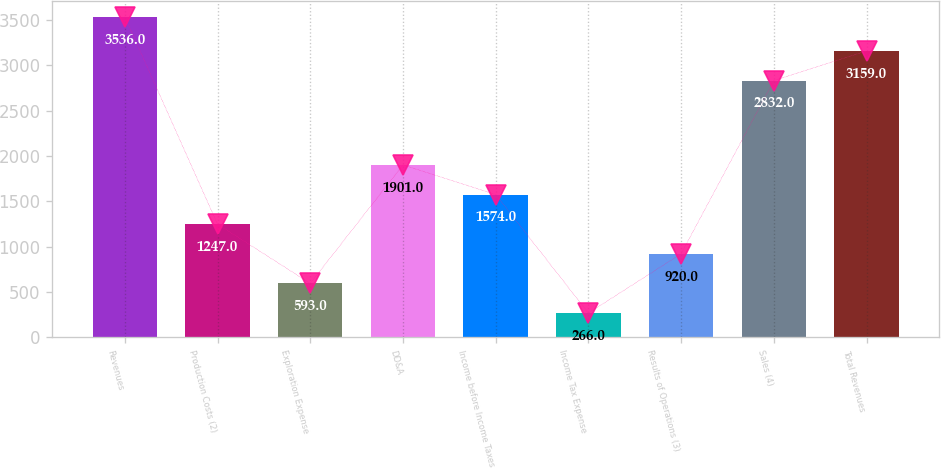Convert chart. <chart><loc_0><loc_0><loc_500><loc_500><bar_chart><fcel>Revenues<fcel>Production Costs (2)<fcel>Exploration Expense<fcel>DD&A<fcel>Income before Income Taxes<fcel>Income Tax Expense<fcel>Results of Operations (3)<fcel>Sales (4)<fcel>Total Revenues<nl><fcel>3536<fcel>1247<fcel>593<fcel>1901<fcel>1574<fcel>266<fcel>920<fcel>2832<fcel>3159<nl></chart> 